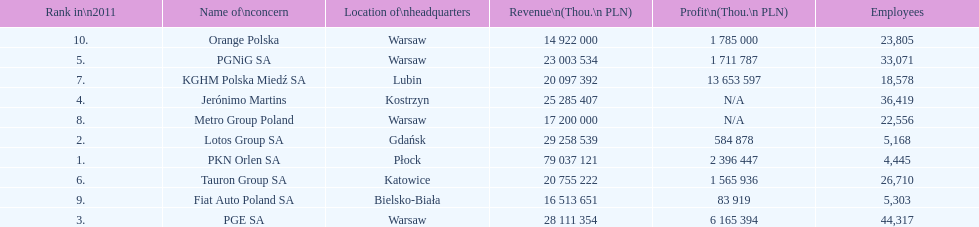What is the number of employees who work for pgnig sa? 33,071. 